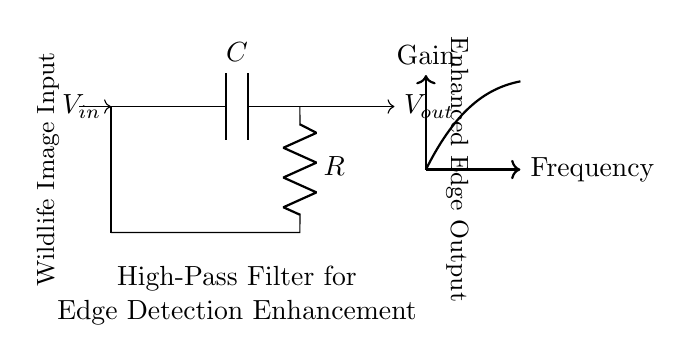What type of filter is represented in this circuit? The circuit diagram shows a high-pass filter, which allows high-frequency signals to pass while attenuating low-frequency signals. This type of filter is characterized specifically for enhancing details such as edges in images.
Answer: high-pass filter What component is used to store energy in this circuit? In the circuit, the capacitor, labeled as C, is the component responsible for storing energy. Capacitors are fundamental in filters, influencing their frequency response.
Answer: capacitor What is the role of the resistor in this circuit? The resistor, labeled as R, plays a crucial role in controlling the time constant of the filter. It works together with the capacitor to determine the cutoff frequency, allowing the filter to behave as desired for edge enhancement.
Answer: control time constant What is the input to the circuit labeled as? The input to the circuit is labeled as Wildlife Image Input, indicating that it processes information derived from wildlife photography to enhance edge features.
Answer: Wildlife Image Input What signifies the output of this high-pass filter? The output of the circuit is labeled as Enhanced Edge Output, which means that the processed signal will highlight edges within the input image, enhancing the visual detail of the wildlife photograph.
Answer: Enhanced Edge Output How does the filter respond to low frequencies based on its type? A high-pass filter, by definition, attenuates low frequencies, effectively reducing their amplitude while allowing higher frequencies to pass through, which is vital for highlighting edges in images.
Answer: attenuates low frequencies What is the relationship between gain and frequency in this circuit? The relationship is depicted by the upward curve in the diagram, which suggests that as the frequency increases, the gain also increases, indicating better response for higher frequency signals that enhance edge detection.
Answer: gain increases with frequency 